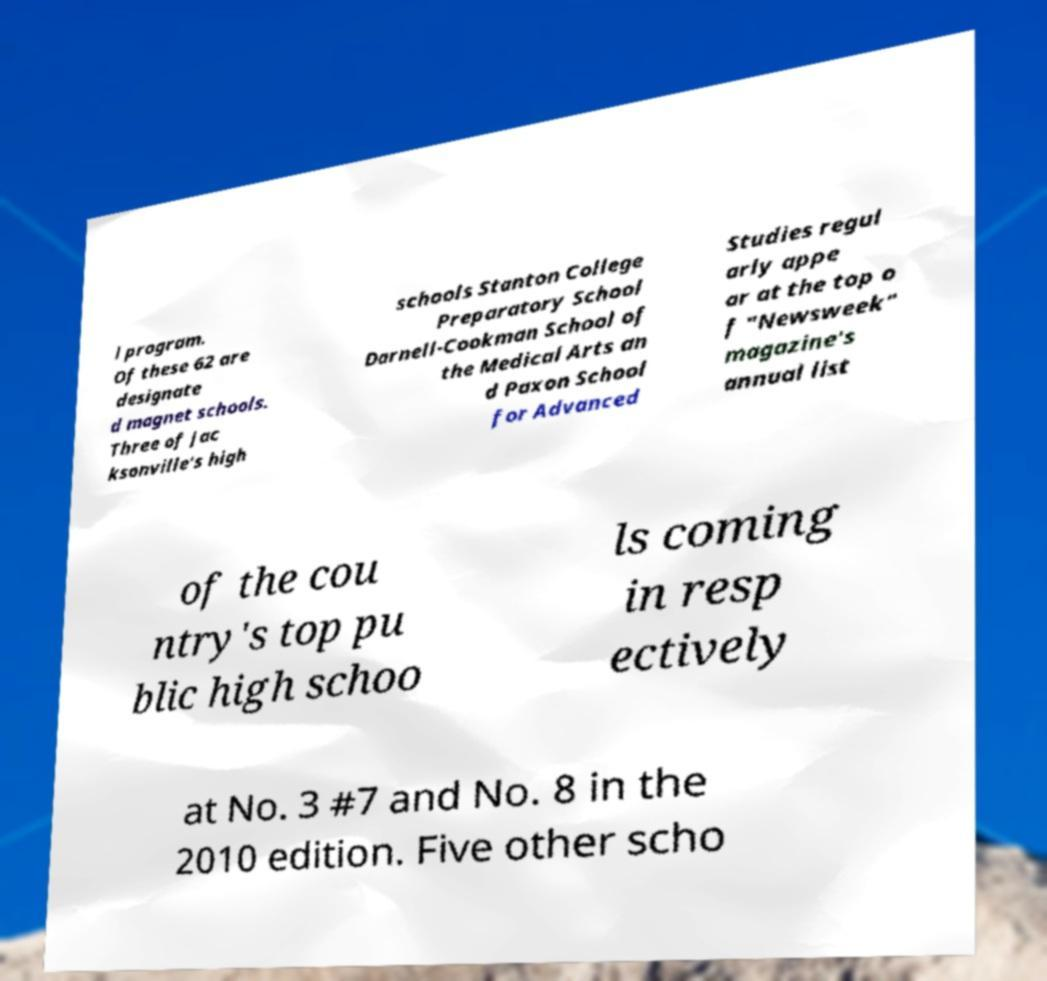Can you accurately transcribe the text from the provided image for me? l program. Of these 62 are designate d magnet schools. Three of Jac ksonville's high schools Stanton College Preparatory School Darnell-Cookman School of the Medical Arts an d Paxon School for Advanced Studies regul arly appe ar at the top o f "Newsweek" magazine's annual list of the cou ntry's top pu blic high schoo ls coming in resp ectively at No. 3 #7 and No. 8 in the 2010 edition. Five other scho 